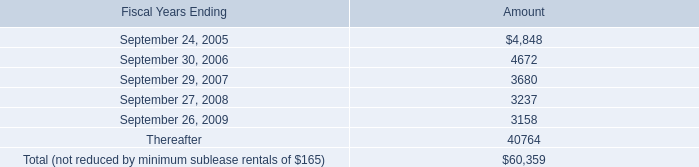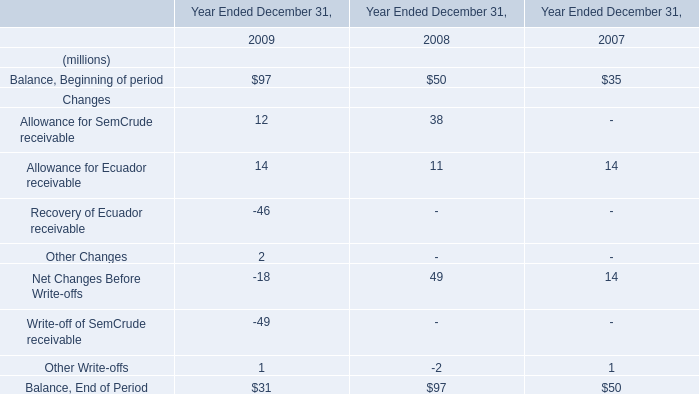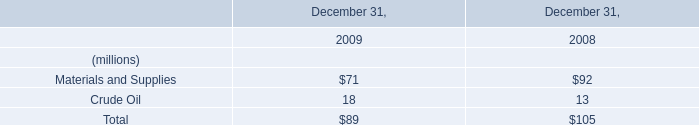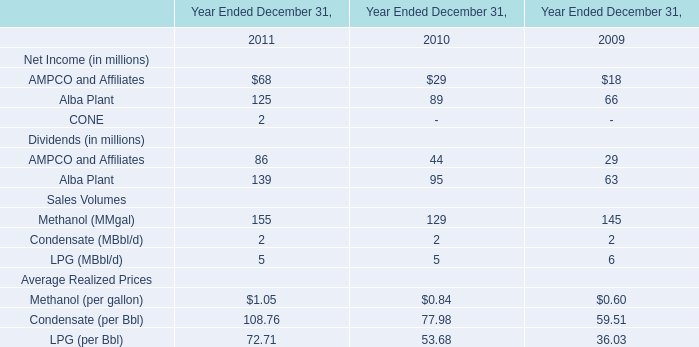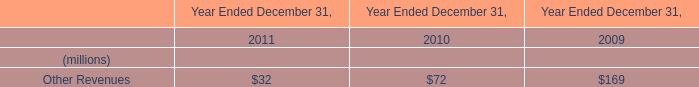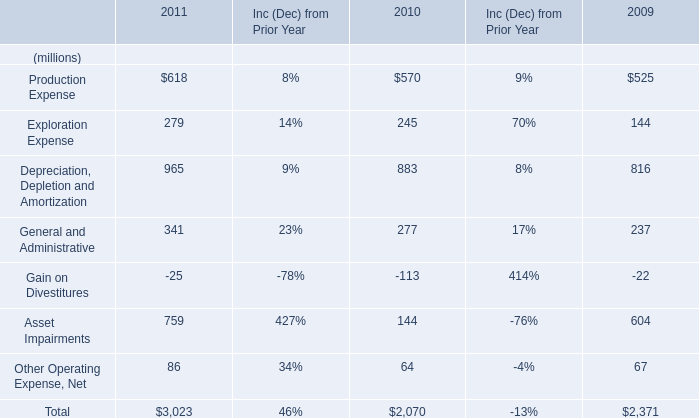What's the sum of the AMPCO and Affiliates for Dividends (in millions) in the years where Other Revenues is positive? (in million) 
Computations: ((86 + 44) + 29)
Answer: 159.0. 